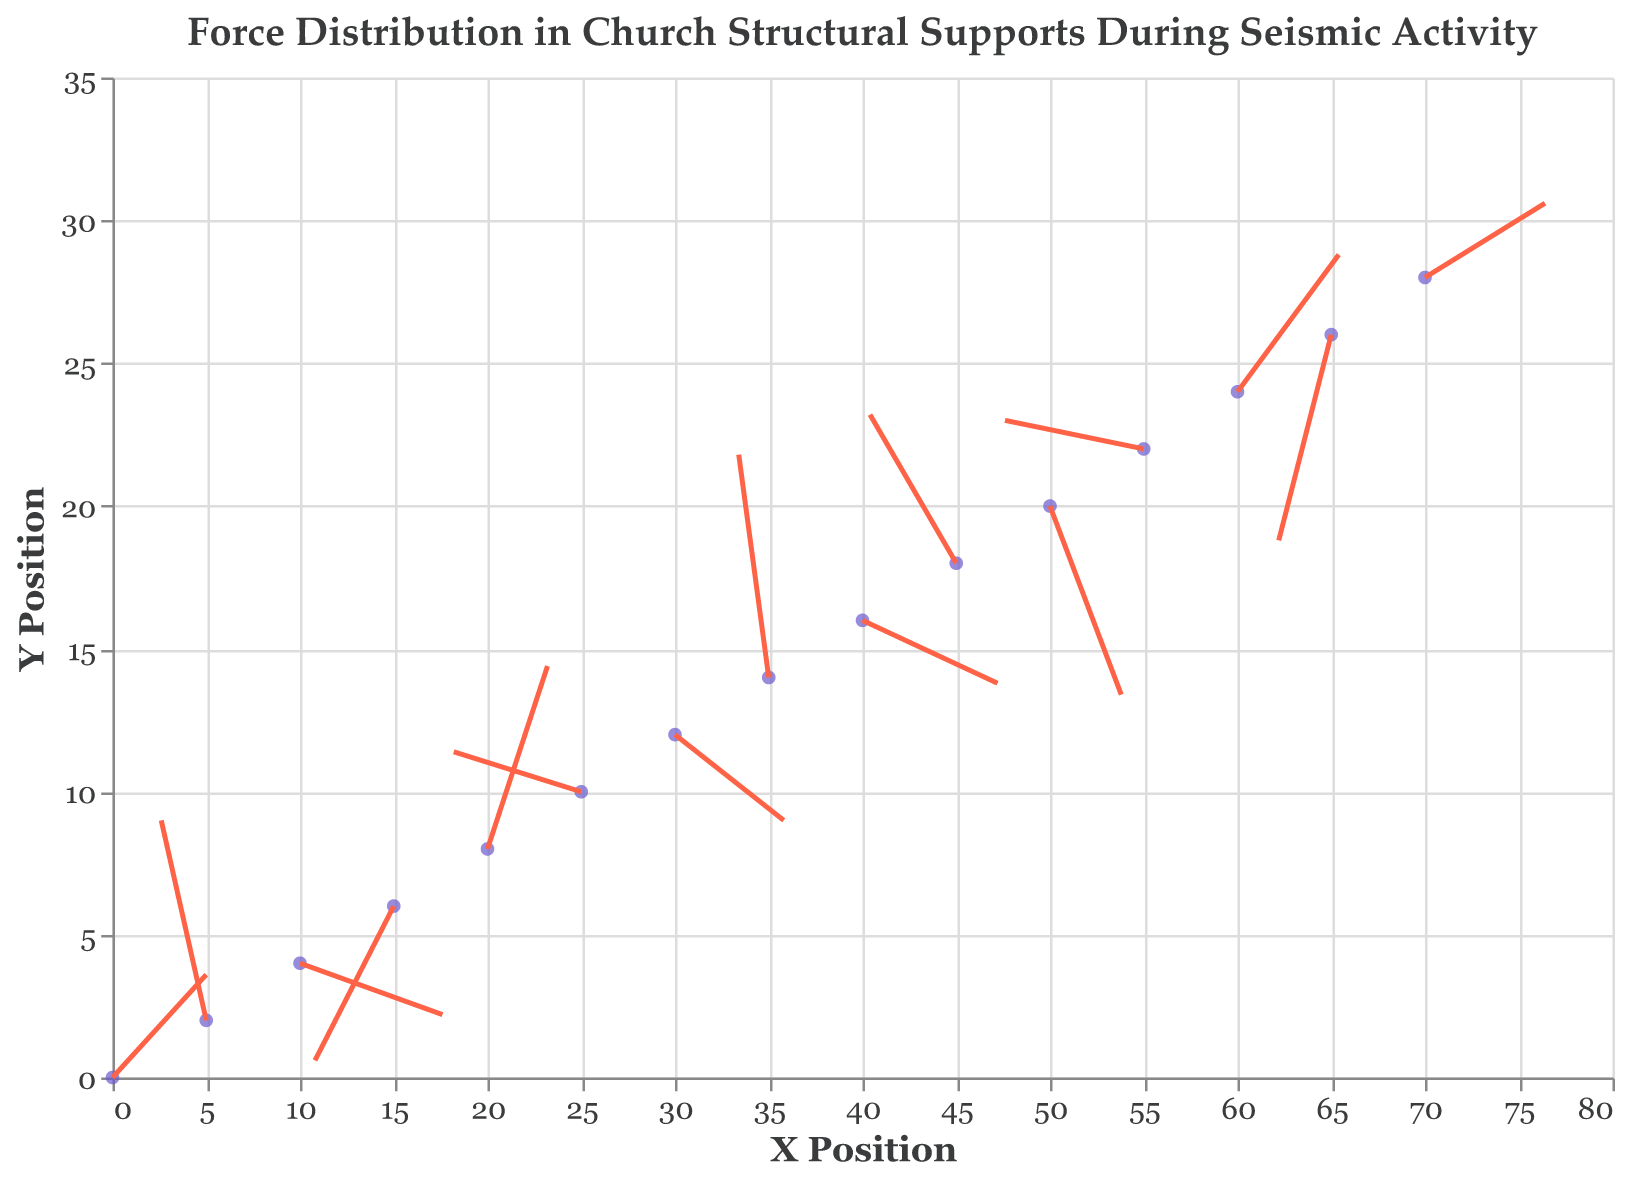What is the title of the plot? The title of the plot is generally displayed at the top and is easy to read.
Answer: Force Distribution in Church Structural Supports During Seismic Activity What do the colors used in the plot represent? The point markers are colored dark blue, and the arrows are orange-red. These colors help differentiate the elements in the plot.
Answer: Points: dark blue, Arrows: orange-red How many data points are plotted on the graph? To find out the number of data points, we can count the individual point markers on the plot.
Answer: 15 What are the x and y positions of the data point where the force vector has the highest magnitude? To find this, we need to scan the plot for the arrow with the longest length, indicative of the highest magnitude.
Answer: (35, 14) Which data point has a force vector pointing predominantly upwards? We look for the data point where the u component is small, and the v component is large and positive, indicating an upward direction.
Answer: (5, 2) Calculate the average magnitude of the force vectors? Add up all the magnitudes and divide by the number of points: (3.1 + 3.7 + 3.9 + 3.4 + 3.6 + 3.5 + 3.3 + 4.0 + 3.8 + 3.5 + 3.8 + 3.7 + 3.6 + 3.9 + 3.5) / 15 = 3.63.
Answer: 3.63 Compare the direction of force between points (40, 16) and (65, 26). Which one has a downward pointing vector? Analyze the v component for both points to determine the direction. Large negative v indicates downward pointing.
Answer: (65, 26) How far does the force vector at (10, 4) extend in the x and y directions? Calculate the extension using (x2 - x) and (y2 - y). For (10, 4) with components (3.8, -0.9), calculate x2 = 10 + 2*3.8 = 17.6 and y2 = 4 + 2*-0.9 = 2.2. Distance in x is 17.6-10 = 7.6 and in y is 2.2-4 = -1.8.
Answer: x-direction: 7.6, y-direction: -1.8 Which force vector has the shortest length, and what is its magnitude? Identify the vector with the shortest length visually, then refer to its magnitude value.
Answer: Vector at (30, 12), Magnitude: 3.3 